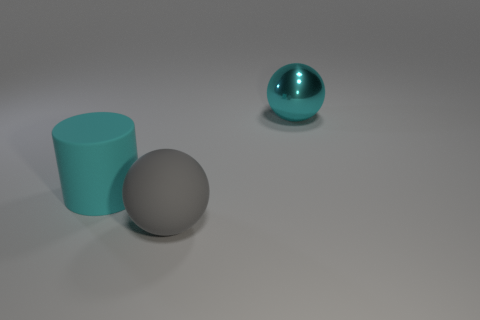Subtract all yellow spheres. Subtract all yellow cylinders. How many spheres are left? 2 Add 3 small purple matte spheres. How many objects exist? 6 Subtract all cylinders. How many objects are left? 2 Subtract 1 gray spheres. How many objects are left? 2 Subtract all large cyan objects. Subtract all big matte spheres. How many objects are left? 0 Add 1 big gray balls. How many big gray balls are left? 2 Add 3 large cyan cylinders. How many large cyan cylinders exist? 4 